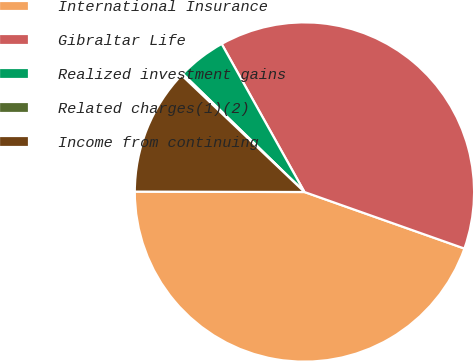Convert chart to OTSL. <chart><loc_0><loc_0><loc_500><loc_500><pie_chart><fcel>International Insurance<fcel>Gibraltar Life<fcel>Realized investment gains<fcel>Related charges(1)(2)<fcel>Income from continuing<nl><fcel>44.63%<fcel>38.52%<fcel>4.62%<fcel>0.17%<fcel>12.06%<nl></chart> 